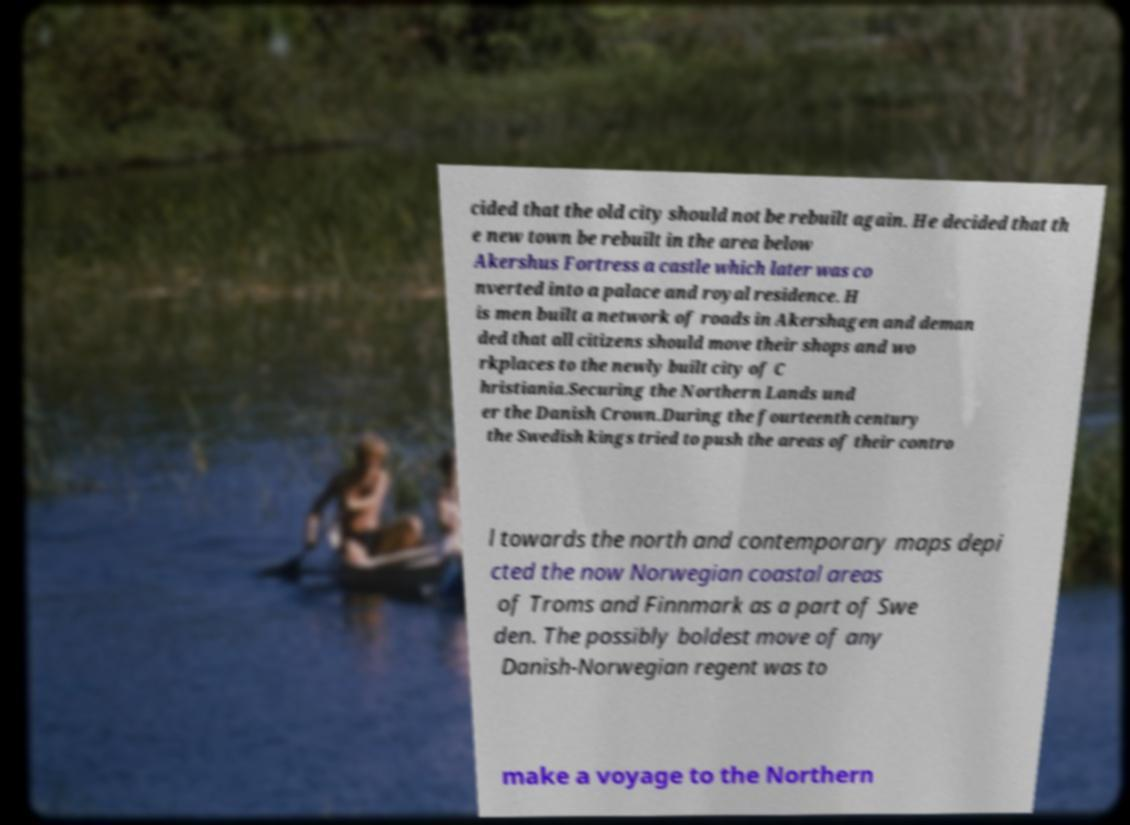Could you extract and type out the text from this image? cided that the old city should not be rebuilt again. He decided that th e new town be rebuilt in the area below Akershus Fortress a castle which later was co nverted into a palace and royal residence. H is men built a network of roads in Akershagen and deman ded that all citizens should move their shops and wo rkplaces to the newly built city of C hristiania.Securing the Northern Lands und er the Danish Crown.During the fourteenth century the Swedish kings tried to push the areas of their contro l towards the north and contemporary maps depi cted the now Norwegian coastal areas of Troms and Finnmark as a part of Swe den. The possibly boldest move of any Danish-Norwegian regent was to make a voyage to the Northern 